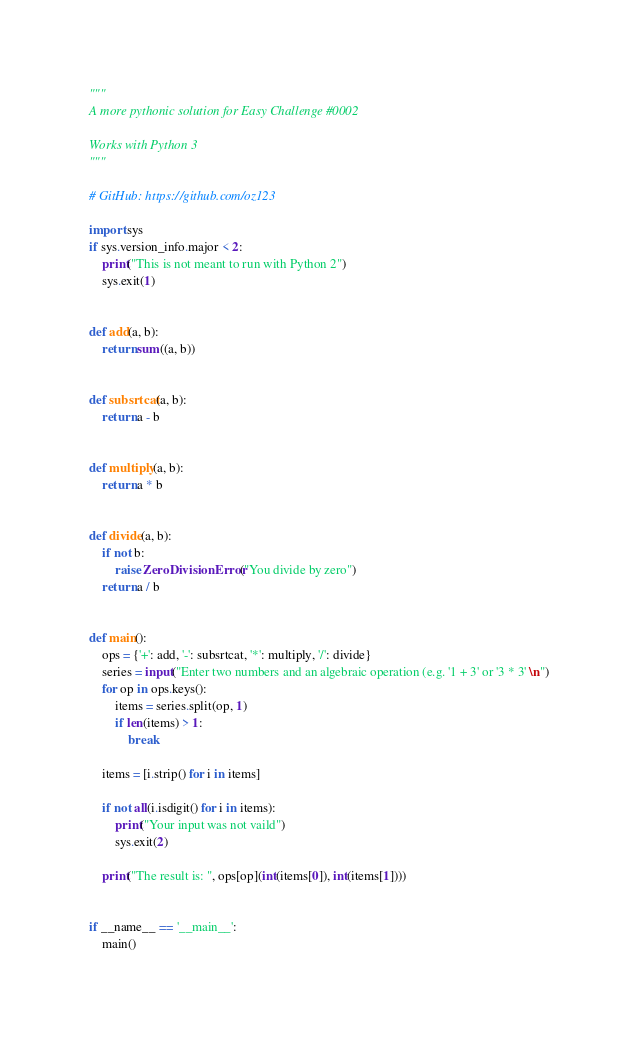<code> <loc_0><loc_0><loc_500><loc_500><_Python_>"""
A more pythonic solution for Easy Challenge #0002

Works with Python 3
"""

# GitHub: https://github.com/oz123

import sys
if sys.version_info.major < 2:
    print("This is not meant to run with Python 2")
    sys.exit(1)


def add(a, b):
    return sum((a, b))


def subsrtcat(a, b):
    return a - b


def multiply(a, b):
    return a * b


def divide(a, b):
    if not b:
        raise ZeroDivisionError("You divide by zero")
    return a / b


def main():
    ops = {'+': add, '-': subsrtcat, '*': multiply, '/': divide}
    series = input("Enter two numbers and an algebraic operation (e.g. '1 + 3' or '3 * 3' \n")
    for op in ops.keys():
        items = series.split(op, 1)
        if len(items) > 1:
            break

    items = [i.strip() for i in items]

    if not all(i.isdigit() for i in items):
        print("Your input was not vaild")
        sys.exit(2)

    print("The result is: ", ops[op](int(items[0]), int(items[1])))


if __name__ == '__main__':
    main()
</code> 